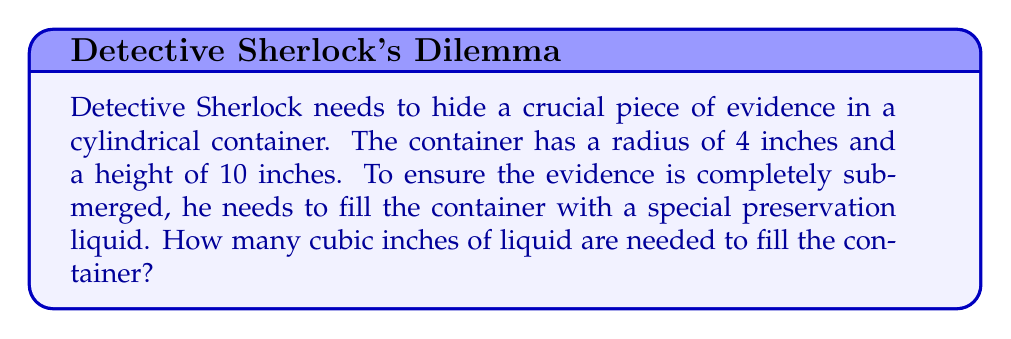Could you help me with this problem? To solve this problem, we need to calculate the volume of a cylinder. The formula for the volume of a cylinder is:

$$V = \pi r^2 h$$

Where:
$V$ = volume
$r$ = radius of the base
$h$ = height of the cylinder

Given:
$r = 4$ inches
$h = 10$ inches

Let's substitute these values into the formula:

$$V = \pi (4\text{ in})^2 (10\text{ in})$$

Simplify:
$$V = \pi (16\text{ in}^2) (10\text{ in})$$
$$V = 160\pi\text{ in}^3$$

Using 3.14159 as an approximation for $\pi$:

$$V \approx 160 \times 3.14159\text{ in}^3$$
$$V \approx 502.654\text{ in}^3$$

Rounding to the nearest cubic inch:

$$V \approx 503\text{ in}^3$$

Therefore, Detective Sherlock needs approximately 503 cubic inches of the special preservation liquid to fill the cylindrical container and completely submerge the evidence.
Answer: $503\text{ in}^3$ 